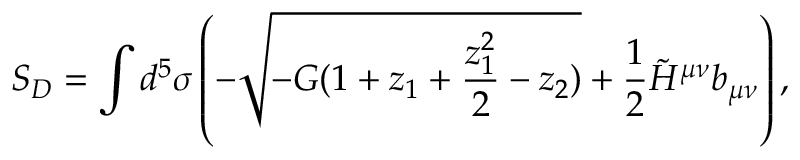Convert formula to latex. <formula><loc_0><loc_0><loc_500><loc_500>S _ { D } = \int d ^ { 5 } \sigma \left ( - \sqrt { - G ( 1 + z _ { 1 } + { \frac { z _ { 1 } ^ { 2 } } { 2 } } - z _ { 2 } ) } + { \frac { 1 } { 2 } } \tilde { H } ^ { \mu \nu } b _ { \mu \nu } \right ) ,</formula> 